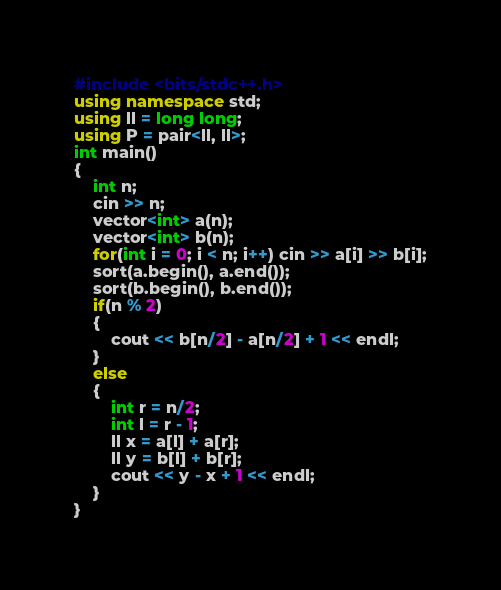Convert code to text. <code><loc_0><loc_0><loc_500><loc_500><_C++_>#include <bits/stdc++.h>
using namespace std;
using ll = long long;
using P = pair<ll, ll>;
int main()
{
    int n;
    cin >> n;
    vector<int> a(n);
    vector<int> b(n);
    for(int i = 0; i < n; i++) cin >> a[i] >> b[i];
    sort(a.begin(), a.end());
    sort(b.begin(), b.end());
    if(n % 2)
    {
        cout << b[n/2] - a[n/2] + 1 << endl;
    }
    else
    {
        int r = n/2;
        int l = r - 1;
        ll x = a[l] + a[r];
        ll y = b[l] + b[r];
        cout << y - x + 1 << endl;
    }
}
</code> 